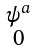<formula> <loc_0><loc_0><loc_500><loc_500>\begin{smallmatrix} \psi ^ { a } \\ 0 \end{smallmatrix}</formula> 